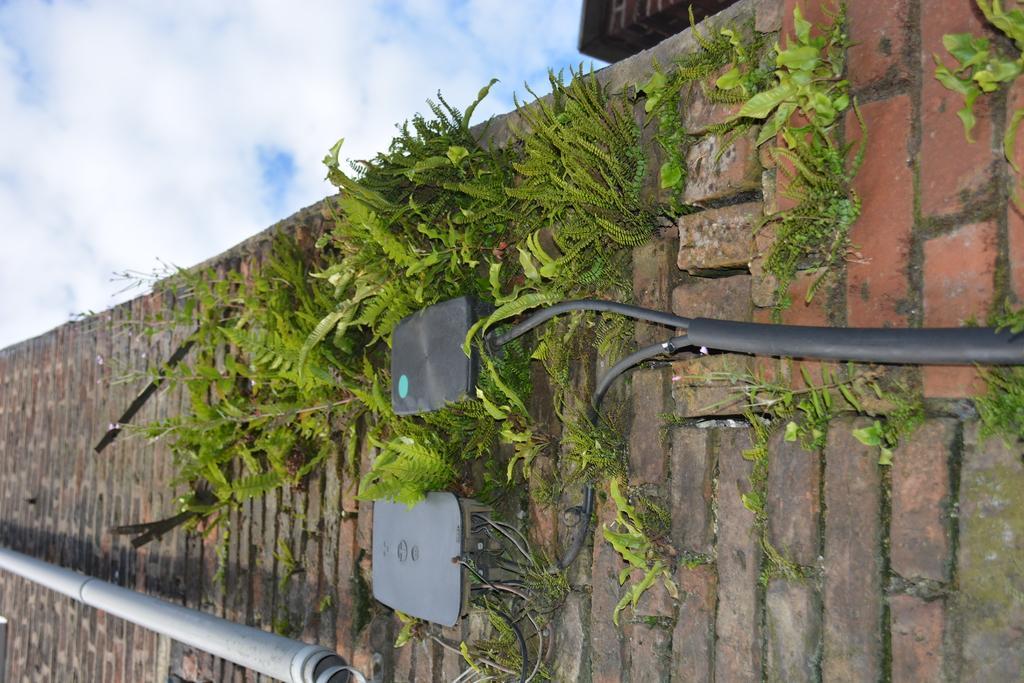Could you give a brief overview of what you see in this image? In this image we can see the wall. And we can see the tiny plants. And we can see some metal objects. And we can see the clouds in the sky. 